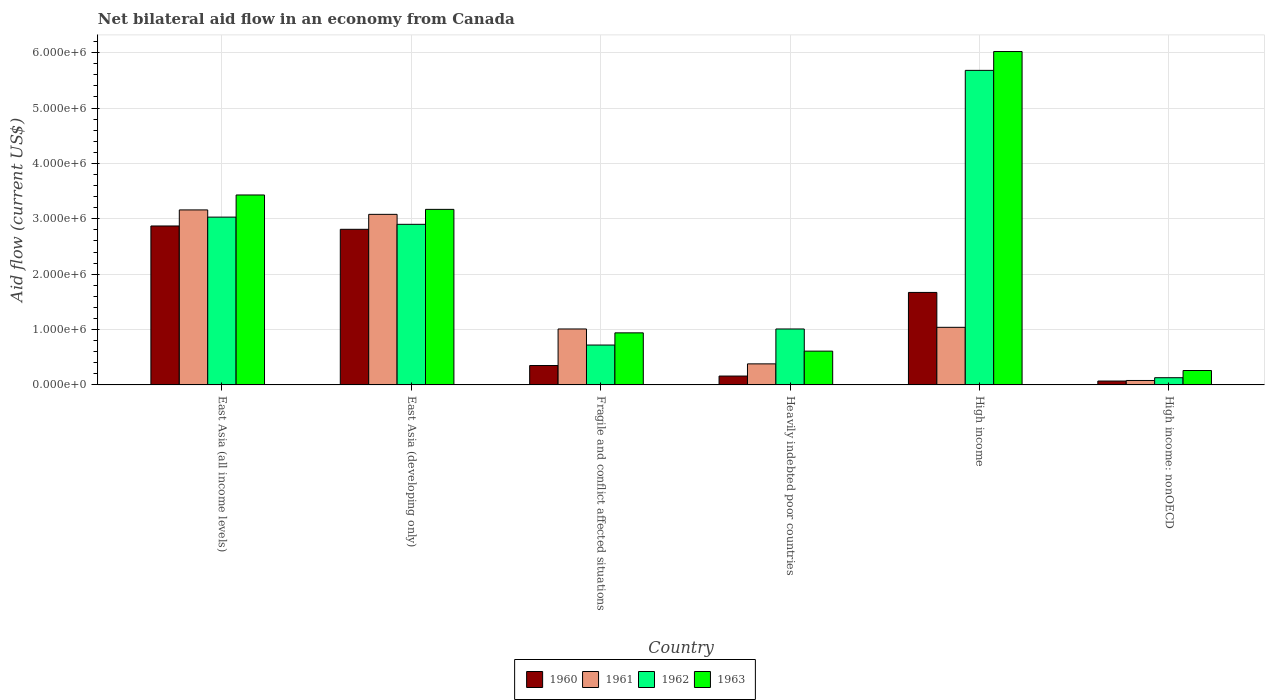How many groups of bars are there?
Offer a terse response. 6. Are the number of bars per tick equal to the number of legend labels?
Offer a very short reply. Yes. Are the number of bars on each tick of the X-axis equal?
Make the answer very short. Yes. How many bars are there on the 1st tick from the right?
Provide a short and direct response. 4. In how many cases, is the number of bars for a given country not equal to the number of legend labels?
Provide a succinct answer. 0. What is the net bilateral aid flow in 1961 in East Asia (all income levels)?
Ensure brevity in your answer.  3.16e+06. Across all countries, what is the maximum net bilateral aid flow in 1963?
Ensure brevity in your answer.  6.02e+06. Across all countries, what is the minimum net bilateral aid flow in 1961?
Ensure brevity in your answer.  8.00e+04. In which country was the net bilateral aid flow in 1960 minimum?
Your response must be concise. High income: nonOECD. What is the total net bilateral aid flow in 1962 in the graph?
Offer a terse response. 1.35e+07. What is the difference between the net bilateral aid flow in 1962 in East Asia (all income levels) and that in Heavily indebted poor countries?
Your answer should be very brief. 2.02e+06. What is the difference between the net bilateral aid flow in 1962 in Heavily indebted poor countries and the net bilateral aid flow in 1960 in High income: nonOECD?
Your response must be concise. 9.40e+05. What is the average net bilateral aid flow in 1961 per country?
Offer a very short reply. 1.46e+06. What is the difference between the net bilateral aid flow of/in 1960 and net bilateral aid flow of/in 1963 in Heavily indebted poor countries?
Your answer should be compact. -4.50e+05. In how many countries, is the net bilateral aid flow in 1961 greater than 3600000 US$?
Make the answer very short. 0. What is the ratio of the net bilateral aid flow in 1963 in East Asia (developing only) to that in Heavily indebted poor countries?
Offer a very short reply. 5.2. Is the net bilateral aid flow in 1961 in East Asia (all income levels) less than that in High income?
Ensure brevity in your answer.  No. Is the difference between the net bilateral aid flow in 1960 in East Asia (all income levels) and Fragile and conflict affected situations greater than the difference between the net bilateral aid flow in 1963 in East Asia (all income levels) and Fragile and conflict affected situations?
Your answer should be compact. Yes. What is the difference between the highest and the second highest net bilateral aid flow in 1962?
Ensure brevity in your answer.  2.78e+06. What is the difference between the highest and the lowest net bilateral aid flow in 1962?
Your response must be concise. 5.55e+06. In how many countries, is the net bilateral aid flow in 1960 greater than the average net bilateral aid flow in 1960 taken over all countries?
Offer a terse response. 3. Is it the case that in every country, the sum of the net bilateral aid flow in 1960 and net bilateral aid flow in 1961 is greater than the sum of net bilateral aid flow in 1963 and net bilateral aid flow in 1962?
Make the answer very short. No. What does the 3rd bar from the right in High income represents?
Keep it short and to the point. 1961. Is it the case that in every country, the sum of the net bilateral aid flow in 1961 and net bilateral aid flow in 1960 is greater than the net bilateral aid flow in 1963?
Give a very brief answer. No. How many countries are there in the graph?
Ensure brevity in your answer.  6. Does the graph contain grids?
Keep it short and to the point. Yes. How many legend labels are there?
Provide a short and direct response. 4. How are the legend labels stacked?
Give a very brief answer. Horizontal. What is the title of the graph?
Keep it short and to the point. Net bilateral aid flow in an economy from Canada. Does "1995" appear as one of the legend labels in the graph?
Offer a very short reply. No. What is the Aid flow (current US$) of 1960 in East Asia (all income levels)?
Your answer should be very brief. 2.87e+06. What is the Aid flow (current US$) of 1961 in East Asia (all income levels)?
Give a very brief answer. 3.16e+06. What is the Aid flow (current US$) in 1962 in East Asia (all income levels)?
Ensure brevity in your answer.  3.03e+06. What is the Aid flow (current US$) of 1963 in East Asia (all income levels)?
Make the answer very short. 3.43e+06. What is the Aid flow (current US$) of 1960 in East Asia (developing only)?
Provide a short and direct response. 2.81e+06. What is the Aid flow (current US$) in 1961 in East Asia (developing only)?
Provide a short and direct response. 3.08e+06. What is the Aid flow (current US$) of 1962 in East Asia (developing only)?
Your answer should be compact. 2.90e+06. What is the Aid flow (current US$) of 1963 in East Asia (developing only)?
Your answer should be compact. 3.17e+06. What is the Aid flow (current US$) of 1960 in Fragile and conflict affected situations?
Provide a succinct answer. 3.50e+05. What is the Aid flow (current US$) of 1961 in Fragile and conflict affected situations?
Ensure brevity in your answer.  1.01e+06. What is the Aid flow (current US$) of 1962 in Fragile and conflict affected situations?
Provide a short and direct response. 7.20e+05. What is the Aid flow (current US$) in 1963 in Fragile and conflict affected situations?
Your answer should be very brief. 9.40e+05. What is the Aid flow (current US$) in 1962 in Heavily indebted poor countries?
Provide a succinct answer. 1.01e+06. What is the Aid flow (current US$) in 1960 in High income?
Your response must be concise. 1.67e+06. What is the Aid flow (current US$) in 1961 in High income?
Offer a very short reply. 1.04e+06. What is the Aid flow (current US$) in 1962 in High income?
Ensure brevity in your answer.  5.68e+06. What is the Aid flow (current US$) of 1963 in High income?
Offer a terse response. 6.02e+06. Across all countries, what is the maximum Aid flow (current US$) in 1960?
Provide a short and direct response. 2.87e+06. Across all countries, what is the maximum Aid flow (current US$) of 1961?
Offer a very short reply. 3.16e+06. Across all countries, what is the maximum Aid flow (current US$) in 1962?
Make the answer very short. 5.68e+06. Across all countries, what is the maximum Aid flow (current US$) of 1963?
Keep it short and to the point. 6.02e+06. Across all countries, what is the minimum Aid flow (current US$) in 1960?
Your answer should be very brief. 7.00e+04. Across all countries, what is the minimum Aid flow (current US$) of 1962?
Offer a very short reply. 1.30e+05. What is the total Aid flow (current US$) in 1960 in the graph?
Provide a short and direct response. 7.93e+06. What is the total Aid flow (current US$) in 1961 in the graph?
Offer a very short reply. 8.75e+06. What is the total Aid flow (current US$) in 1962 in the graph?
Make the answer very short. 1.35e+07. What is the total Aid flow (current US$) of 1963 in the graph?
Ensure brevity in your answer.  1.44e+07. What is the difference between the Aid flow (current US$) of 1960 in East Asia (all income levels) and that in East Asia (developing only)?
Give a very brief answer. 6.00e+04. What is the difference between the Aid flow (current US$) of 1961 in East Asia (all income levels) and that in East Asia (developing only)?
Provide a short and direct response. 8.00e+04. What is the difference between the Aid flow (current US$) of 1962 in East Asia (all income levels) and that in East Asia (developing only)?
Keep it short and to the point. 1.30e+05. What is the difference between the Aid flow (current US$) of 1960 in East Asia (all income levels) and that in Fragile and conflict affected situations?
Provide a succinct answer. 2.52e+06. What is the difference between the Aid flow (current US$) in 1961 in East Asia (all income levels) and that in Fragile and conflict affected situations?
Ensure brevity in your answer.  2.15e+06. What is the difference between the Aid flow (current US$) in 1962 in East Asia (all income levels) and that in Fragile and conflict affected situations?
Make the answer very short. 2.31e+06. What is the difference between the Aid flow (current US$) in 1963 in East Asia (all income levels) and that in Fragile and conflict affected situations?
Your answer should be very brief. 2.49e+06. What is the difference between the Aid flow (current US$) in 1960 in East Asia (all income levels) and that in Heavily indebted poor countries?
Your answer should be compact. 2.71e+06. What is the difference between the Aid flow (current US$) in 1961 in East Asia (all income levels) and that in Heavily indebted poor countries?
Make the answer very short. 2.78e+06. What is the difference between the Aid flow (current US$) of 1962 in East Asia (all income levels) and that in Heavily indebted poor countries?
Your answer should be very brief. 2.02e+06. What is the difference between the Aid flow (current US$) of 1963 in East Asia (all income levels) and that in Heavily indebted poor countries?
Your response must be concise. 2.82e+06. What is the difference between the Aid flow (current US$) of 1960 in East Asia (all income levels) and that in High income?
Offer a very short reply. 1.20e+06. What is the difference between the Aid flow (current US$) in 1961 in East Asia (all income levels) and that in High income?
Offer a terse response. 2.12e+06. What is the difference between the Aid flow (current US$) in 1962 in East Asia (all income levels) and that in High income?
Your answer should be compact. -2.65e+06. What is the difference between the Aid flow (current US$) of 1963 in East Asia (all income levels) and that in High income?
Offer a very short reply. -2.59e+06. What is the difference between the Aid flow (current US$) in 1960 in East Asia (all income levels) and that in High income: nonOECD?
Offer a very short reply. 2.80e+06. What is the difference between the Aid flow (current US$) in 1961 in East Asia (all income levels) and that in High income: nonOECD?
Give a very brief answer. 3.08e+06. What is the difference between the Aid flow (current US$) of 1962 in East Asia (all income levels) and that in High income: nonOECD?
Make the answer very short. 2.90e+06. What is the difference between the Aid flow (current US$) in 1963 in East Asia (all income levels) and that in High income: nonOECD?
Offer a very short reply. 3.17e+06. What is the difference between the Aid flow (current US$) of 1960 in East Asia (developing only) and that in Fragile and conflict affected situations?
Keep it short and to the point. 2.46e+06. What is the difference between the Aid flow (current US$) of 1961 in East Asia (developing only) and that in Fragile and conflict affected situations?
Your answer should be compact. 2.07e+06. What is the difference between the Aid flow (current US$) in 1962 in East Asia (developing only) and that in Fragile and conflict affected situations?
Your answer should be compact. 2.18e+06. What is the difference between the Aid flow (current US$) in 1963 in East Asia (developing only) and that in Fragile and conflict affected situations?
Provide a short and direct response. 2.23e+06. What is the difference between the Aid flow (current US$) in 1960 in East Asia (developing only) and that in Heavily indebted poor countries?
Make the answer very short. 2.65e+06. What is the difference between the Aid flow (current US$) in 1961 in East Asia (developing only) and that in Heavily indebted poor countries?
Your answer should be compact. 2.70e+06. What is the difference between the Aid flow (current US$) of 1962 in East Asia (developing only) and that in Heavily indebted poor countries?
Keep it short and to the point. 1.89e+06. What is the difference between the Aid flow (current US$) in 1963 in East Asia (developing only) and that in Heavily indebted poor countries?
Your response must be concise. 2.56e+06. What is the difference between the Aid flow (current US$) in 1960 in East Asia (developing only) and that in High income?
Give a very brief answer. 1.14e+06. What is the difference between the Aid flow (current US$) of 1961 in East Asia (developing only) and that in High income?
Offer a very short reply. 2.04e+06. What is the difference between the Aid flow (current US$) in 1962 in East Asia (developing only) and that in High income?
Offer a terse response. -2.78e+06. What is the difference between the Aid flow (current US$) in 1963 in East Asia (developing only) and that in High income?
Keep it short and to the point. -2.85e+06. What is the difference between the Aid flow (current US$) in 1960 in East Asia (developing only) and that in High income: nonOECD?
Offer a very short reply. 2.74e+06. What is the difference between the Aid flow (current US$) of 1961 in East Asia (developing only) and that in High income: nonOECD?
Your response must be concise. 3.00e+06. What is the difference between the Aid flow (current US$) of 1962 in East Asia (developing only) and that in High income: nonOECD?
Give a very brief answer. 2.77e+06. What is the difference between the Aid flow (current US$) in 1963 in East Asia (developing only) and that in High income: nonOECD?
Offer a very short reply. 2.91e+06. What is the difference between the Aid flow (current US$) in 1961 in Fragile and conflict affected situations and that in Heavily indebted poor countries?
Offer a terse response. 6.30e+05. What is the difference between the Aid flow (current US$) of 1962 in Fragile and conflict affected situations and that in Heavily indebted poor countries?
Your answer should be very brief. -2.90e+05. What is the difference between the Aid flow (current US$) of 1963 in Fragile and conflict affected situations and that in Heavily indebted poor countries?
Make the answer very short. 3.30e+05. What is the difference between the Aid flow (current US$) in 1960 in Fragile and conflict affected situations and that in High income?
Make the answer very short. -1.32e+06. What is the difference between the Aid flow (current US$) of 1962 in Fragile and conflict affected situations and that in High income?
Give a very brief answer. -4.96e+06. What is the difference between the Aid flow (current US$) in 1963 in Fragile and conflict affected situations and that in High income?
Offer a terse response. -5.08e+06. What is the difference between the Aid flow (current US$) in 1961 in Fragile and conflict affected situations and that in High income: nonOECD?
Ensure brevity in your answer.  9.30e+05. What is the difference between the Aid flow (current US$) of 1962 in Fragile and conflict affected situations and that in High income: nonOECD?
Your answer should be very brief. 5.90e+05. What is the difference between the Aid flow (current US$) of 1963 in Fragile and conflict affected situations and that in High income: nonOECD?
Your response must be concise. 6.80e+05. What is the difference between the Aid flow (current US$) of 1960 in Heavily indebted poor countries and that in High income?
Give a very brief answer. -1.51e+06. What is the difference between the Aid flow (current US$) of 1961 in Heavily indebted poor countries and that in High income?
Ensure brevity in your answer.  -6.60e+05. What is the difference between the Aid flow (current US$) in 1962 in Heavily indebted poor countries and that in High income?
Give a very brief answer. -4.67e+06. What is the difference between the Aid flow (current US$) of 1963 in Heavily indebted poor countries and that in High income?
Make the answer very short. -5.41e+06. What is the difference between the Aid flow (current US$) in 1961 in Heavily indebted poor countries and that in High income: nonOECD?
Offer a terse response. 3.00e+05. What is the difference between the Aid flow (current US$) of 1962 in Heavily indebted poor countries and that in High income: nonOECD?
Your answer should be compact. 8.80e+05. What is the difference between the Aid flow (current US$) of 1963 in Heavily indebted poor countries and that in High income: nonOECD?
Your answer should be compact. 3.50e+05. What is the difference between the Aid flow (current US$) of 1960 in High income and that in High income: nonOECD?
Your answer should be compact. 1.60e+06. What is the difference between the Aid flow (current US$) of 1961 in High income and that in High income: nonOECD?
Your answer should be compact. 9.60e+05. What is the difference between the Aid flow (current US$) in 1962 in High income and that in High income: nonOECD?
Keep it short and to the point. 5.55e+06. What is the difference between the Aid flow (current US$) in 1963 in High income and that in High income: nonOECD?
Give a very brief answer. 5.76e+06. What is the difference between the Aid flow (current US$) in 1960 in East Asia (all income levels) and the Aid flow (current US$) in 1961 in East Asia (developing only)?
Your response must be concise. -2.10e+05. What is the difference between the Aid flow (current US$) in 1960 in East Asia (all income levels) and the Aid flow (current US$) in 1962 in East Asia (developing only)?
Offer a very short reply. -3.00e+04. What is the difference between the Aid flow (current US$) in 1961 in East Asia (all income levels) and the Aid flow (current US$) in 1962 in East Asia (developing only)?
Your answer should be compact. 2.60e+05. What is the difference between the Aid flow (current US$) in 1961 in East Asia (all income levels) and the Aid flow (current US$) in 1963 in East Asia (developing only)?
Offer a terse response. -10000. What is the difference between the Aid flow (current US$) in 1960 in East Asia (all income levels) and the Aid flow (current US$) in 1961 in Fragile and conflict affected situations?
Make the answer very short. 1.86e+06. What is the difference between the Aid flow (current US$) in 1960 in East Asia (all income levels) and the Aid flow (current US$) in 1962 in Fragile and conflict affected situations?
Give a very brief answer. 2.15e+06. What is the difference between the Aid flow (current US$) of 1960 in East Asia (all income levels) and the Aid flow (current US$) of 1963 in Fragile and conflict affected situations?
Ensure brevity in your answer.  1.93e+06. What is the difference between the Aid flow (current US$) in 1961 in East Asia (all income levels) and the Aid flow (current US$) in 1962 in Fragile and conflict affected situations?
Ensure brevity in your answer.  2.44e+06. What is the difference between the Aid flow (current US$) of 1961 in East Asia (all income levels) and the Aid flow (current US$) of 1963 in Fragile and conflict affected situations?
Provide a succinct answer. 2.22e+06. What is the difference between the Aid flow (current US$) in 1962 in East Asia (all income levels) and the Aid flow (current US$) in 1963 in Fragile and conflict affected situations?
Ensure brevity in your answer.  2.09e+06. What is the difference between the Aid flow (current US$) in 1960 in East Asia (all income levels) and the Aid flow (current US$) in 1961 in Heavily indebted poor countries?
Provide a succinct answer. 2.49e+06. What is the difference between the Aid flow (current US$) in 1960 in East Asia (all income levels) and the Aid flow (current US$) in 1962 in Heavily indebted poor countries?
Provide a short and direct response. 1.86e+06. What is the difference between the Aid flow (current US$) of 1960 in East Asia (all income levels) and the Aid flow (current US$) of 1963 in Heavily indebted poor countries?
Your response must be concise. 2.26e+06. What is the difference between the Aid flow (current US$) in 1961 in East Asia (all income levels) and the Aid flow (current US$) in 1962 in Heavily indebted poor countries?
Ensure brevity in your answer.  2.15e+06. What is the difference between the Aid flow (current US$) in 1961 in East Asia (all income levels) and the Aid flow (current US$) in 1963 in Heavily indebted poor countries?
Provide a short and direct response. 2.55e+06. What is the difference between the Aid flow (current US$) of 1962 in East Asia (all income levels) and the Aid flow (current US$) of 1963 in Heavily indebted poor countries?
Provide a succinct answer. 2.42e+06. What is the difference between the Aid flow (current US$) in 1960 in East Asia (all income levels) and the Aid flow (current US$) in 1961 in High income?
Your answer should be very brief. 1.83e+06. What is the difference between the Aid flow (current US$) of 1960 in East Asia (all income levels) and the Aid flow (current US$) of 1962 in High income?
Offer a very short reply. -2.81e+06. What is the difference between the Aid flow (current US$) of 1960 in East Asia (all income levels) and the Aid flow (current US$) of 1963 in High income?
Ensure brevity in your answer.  -3.15e+06. What is the difference between the Aid flow (current US$) in 1961 in East Asia (all income levels) and the Aid flow (current US$) in 1962 in High income?
Provide a succinct answer. -2.52e+06. What is the difference between the Aid flow (current US$) in 1961 in East Asia (all income levels) and the Aid flow (current US$) in 1963 in High income?
Make the answer very short. -2.86e+06. What is the difference between the Aid flow (current US$) of 1962 in East Asia (all income levels) and the Aid flow (current US$) of 1963 in High income?
Offer a terse response. -2.99e+06. What is the difference between the Aid flow (current US$) in 1960 in East Asia (all income levels) and the Aid flow (current US$) in 1961 in High income: nonOECD?
Provide a short and direct response. 2.79e+06. What is the difference between the Aid flow (current US$) of 1960 in East Asia (all income levels) and the Aid flow (current US$) of 1962 in High income: nonOECD?
Keep it short and to the point. 2.74e+06. What is the difference between the Aid flow (current US$) of 1960 in East Asia (all income levels) and the Aid flow (current US$) of 1963 in High income: nonOECD?
Offer a very short reply. 2.61e+06. What is the difference between the Aid flow (current US$) of 1961 in East Asia (all income levels) and the Aid flow (current US$) of 1962 in High income: nonOECD?
Your answer should be very brief. 3.03e+06. What is the difference between the Aid flow (current US$) in 1961 in East Asia (all income levels) and the Aid flow (current US$) in 1963 in High income: nonOECD?
Your response must be concise. 2.90e+06. What is the difference between the Aid flow (current US$) of 1962 in East Asia (all income levels) and the Aid flow (current US$) of 1963 in High income: nonOECD?
Make the answer very short. 2.77e+06. What is the difference between the Aid flow (current US$) of 1960 in East Asia (developing only) and the Aid flow (current US$) of 1961 in Fragile and conflict affected situations?
Keep it short and to the point. 1.80e+06. What is the difference between the Aid flow (current US$) of 1960 in East Asia (developing only) and the Aid flow (current US$) of 1962 in Fragile and conflict affected situations?
Your response must be concise. 2.09e+06. What is the difference between the Aid flow (current US$) in 1960 in East Asia (developing only) and the Aid flow (current US$) in 1963 in Fragile and conflict affected situations?
Give a very brief answer. 1.87e+06. What is the difference between the Aid flow (current US$) of 1961 in East Asia (developing only) and the Aid flow (current US$) of 1962 in Fragile and conflict affected situations?
Offer a very short reply. 2.36e+06. What is the difference between the Aid flow (current US$) of 1961 in East Asia (developing only) and the Aid flow (current US$) of 1963 in Fragile and conflict affected situations?
Provide a succinct answer. 2.14e+06. What is the difference between the Aid flow (current US$) in 1962 in East Asia (developing only) and the Aid flow (current US$) in 1963 in Fragile and conflict affected situations?
Your answer should be compact. 1.96e+06. What is the difference between the Aid flow (current US$) in 1960 in East Asia (developing only) and the Aid flow (current US$) in 1961 in Heavily indebted poor countries?
Keep it short and to the point. 2.43e+06. What is the difference between the Aid flow (current US$) of 1960 in East Asia (developing only) and the Aid flow (current US$) of 1962 in Heavily indebted poor countries?
Ensure brevity in your answer.  1.80e+06. What is the difference between the Aid flow (current US$) in 1960 in East Asia (developing only) and the Aid flow (current US$) in 1963 in Heavily indebted poor countries?
Your answer should be very brief. 2.20e+06. What is the difference between the Aid flow (current US$) of 1961 in East Asia (developing only) and the Aid flow (current US$) of 1962 in Heavily indebted poor countries?
Your response must be concise. 2.07e+06. What is the difference between the Aid flow (current US$) in 1961 in East Asia (developing only) and the Aid flow (current US$) in 1963 in Heavily indebted poor countries?
Make the answer very short. 2.47e+06. What is the difference between the Aid flow (current US$) of 1962 in East Asia (developing only) and the Aid flow (current US$) of 1963 in Heavily indebted poor countries?
Provide a succinct answer. 2.29e+06. What is the difference between the Aid flow (current US$) of 1960 in East Asia (developing only) and the Aid flow (current US$) of 1961 in High income?
Provide a succinct answer. 1.77e+06. What is the difference between the Aid flow (current US$) in 1960 in East Asia (developing only) and the Aid flow (current US$) in 1962 in High income?
Your response must be concise. -2.87e+06. What is the difference between the Aid flow (current US$) of 1960 in East Asia (developing only) and the Aid flow (current US$) of 1963 in High income?
Keep it short and to the point. -3.21e+06. What is the difference between the Aid flow (current US$) of 1961 in East Asia (developing only) and the Aid flow (current US$) of 1962 in High income?
Your response must be concise. -2.60e+06. What is the difference between the Aid flow (current US$) in 1961 in East Asia (developing only) and the Aid flow (current US$) in 1963 in High income?
Your answer should be very brief. -2.94e+06. What is the difference between the Aid flow (current US$) of 1962 in East Asia (developing only) and the Aid flow (current US$) of 1963 in High income?
Your answer should be compact. -3.12e+06. What is the difference between the Aid flow (current US$) of 1960 in East Asia (developing only) and the Aid flow (current US$) of 1961 in High income: nonOECD?
Ensure brevity in your answer.  2.73e+06. What is the difference between the Aid flow (current US$) in 1960 in East Asia (developing only) and the Aid flow (current US$) in 1962 in High income: nonOECD?
Offer a very short reply. 2.68e+06. What is the difference between the Aid flow (current US$) of 1960 in East Asia (developing only) and the Aid flow (current US$) of 1963 in High income: nonOECD?
Keep it short and to the point. 2.55e+06. What is the difference between the Aid flow (current US$) of 1961 in East Asia (developing only) and the Aid flow (current US$) of 1962 in High income: nonOECD?
Offer a terse response. 2.95e+06. What is the difference between the Aid flow (current US$) of 1961 in East Asia (developing only) and the Aid flow (current US$) of 1963 in High income: nonOECD?
Give a very brief answer. 2.82e+06. What is the difference between the Aid flow (current US$) in 1962 in East Asia (developing only) and the Aid flow (current US$) in 1963 in High income: nonOECD?
Provide a short and direct response. 2.64e+06. What is the difference between the Aid flow (current US$) in 1960 in Fragile and conflict affected situations and the Aid flow (current US$) in 1962 in Heavily indebted poor countries?
Your answer should be very brief. -6.60e+05. What is the difference between the Aid flow (current US$) in 1960 in Fragile and conflict affected situations and the Aid flow (current US$) in 1963 in Heavily indebted poor countries?
Offer a terse response. -2.60e+05. What is the difference between the Aid flow (current US$) in 1961 in Fragile and conflict affected situations and the Aid flow (current US$) in 1963 in Heavily indebted poor countries?
Ensure brevity in your answer.  4.00e+05. What is the difference between the Aid flow (current US$) in 1962 in Fragile and conflict affected situations and the Aid flow (current US$) in 1963 in Heavily indebted poor countries?
Offer a very short reply. 1.10e+05. What is the difference between the Aid flow (current US$) of 1960 in Fragile and conflict affected situations and the Aid flow (current US$) of 1961 in High income?
Provide a succinct answer. -6.90e+05. What is the difference between the Aid flow (current US$) of 1960 in Fragile and conflict affected situations and the Aid flow (current US$) of 1962 in High income?
Make the answer very short. -5.33e+06. What is the difference between the Aid flow (current US$) in 1960 in Fragile and conflict affected situations and the Aid flow (current US$) in 1963 in High income?
Ensure brevity in your answer.  -5.67e+06. What is the difference between the Aid flow (current US$) in 1961 in Fragile and conflict affected situations and the Aid flow (current US$) in 1962 in High income?
Your answer should be very brief. -4.67e+06. What is the difference between the Aid flow (current US$) in 1961 in Fragile and conflict affected situations and the Aid flow (current US$) in 1963 in High income?
Offer a very short reply. -5.01e+06. What is the difference between the Aid flow (current US$) in 1962 in Fragile and conflict affected situations and the Aid flow (current US$) in 1963 in High income?
Keep it short and to the point. -5.30e+06. What is the difference between the Aid flow (current US$) in 1960 in Fragile and conflict affected situations and the Aid flow (current US$) in 1961 in High income: nonOECD?
Keep it short and to the point. 2.70e+05. What is the difference between the Aid flow (current US$) in 1960 in Fragile and conflict affected situations and the Aid flow (current US$) in 1962 in High income: nonOECD?
Provide a short and direct response. 2.20e+05. What is the difference between the Aid flow (current US$) in 1961 in Fragile and conflict affected situations and the Aid flow (current US$) in 1962 in High income: nonOECD?
Offer a very short reply. 8.80e+05. What is the difference between the Aid flow (current US$) in 1961 in Fragile and conflict affected situations and the Aid flow (current US$) in 1963 in High income: nonOECD?
Offer a terse response. 7.50e+05. What is the difference between the Aid flow (current US$) of 1962 in Fragile and conflict affected situations and the Aid flow (current US$) of 1963 in High income: nonOECD?
Keep it short and to the point. 4.60e+05. What is the difference between the Aid flow (current US$) of 1960 in Heavily indebted poor countries and the Aid flow (current US$) of 1961 in High income?
Provide a short and direct response. -8.80e+05. What is the difference between the Aid flow (current US$) in 1960 in Heavily indebted poor countries and the Aid flow (current US$) in 1962 in High income?
Keep it short and to the point. -5.52e+06. What is the difference between the Aid flow (current US$) of 1960 in Heavily indebted poor countries and the Aid flow (current US$) of 1963 in High income?
Provide a succinct answer. -5.86e+06. What is the difference between the Aid flow (current US$) in 1961 in Heavily indebted poor countries and the Aid flow (current US$) in 1962 in High income?
Make the answer very short. -5.30e+06. What is the difference between the Aid flow (current US$) in 1961 in Heavily indebted poor countries and the Aid flow (current US$) in 1963 in High income?
Offer a very short reply. -5.64e+06. What is the difference between the Aid flow (current US$) of 1962 in Heavily indebted poor countries and the Aid flow (current US$) of 1963 in High income?
Keep it short and to the point. -5.01e+06. What is the difference between the Aid flow (current US$) in 1960 in Heavily indebted poor countries and the Aid flow (current US$) in 1962 in High income: nonOECD?
Offer a terse response. 3.00e+04. What is the difference between the Aid flow (current US$) in 1962 in Heavily indebted poor countries and the Aid flow (current US$) in 1963 in High income: nonOECD?
Provide a short and direct response. 7.50e+05. What is the difference between the Aid flow (current US$) in 1960 in High income and the Aid flow (current US$) in 1961 in High income: nonOECD?
Provide a succinct answer. 1.59e+06. What is the difference between the Aid flow (current US$) in 1960 in High income and the Aid flow (current US$) in 1962 in High income: nonOECD?
Your answer should be compact. 1.54e+06. What is the difference between the Aid flow (current US$) of 1960 in High income and the Aid flow (current US$) of 1963 in High income: nonOECD?
Your answer should be very brief. 1.41e+06. What is the difference between the Aid flow (current US$) in 1961 in High income and the Aid flow (current US$) in 1962 in High income: nonOECD?
Make the answer very short. 9.10e+05. What is the difference between the Aid flow (current US$) in 1961 in High income and the Aid flow (current US$) in 1963 in High income: nonOECD?
Your answer should be very brief. 7.80e+05. What is the difference between the Aid flow (current US$) in 1962 in High income and the Aid flow (current US$) in 1963 in High income: nonOECD?
Offer a very short reply. 5.42e+06. What is the average Aid flow (current US$) of 1960 per country?
Your answer should be compact. 1.32e+06. What is the average Aid flow (current US$) in 1961 per country?
Offer a terse response. 1.46e+06. What is the average Aid flow (current US$) in 1962 per country?
Provide a short and direct response. 2.24e+06. What is the average Aid flow (current US$) in 1963 per country?
Ensure brevity in your answer.  2.40e+06. What is the difference between the Aid flow (current US$) of 1960 and Aid flow (current US$) of 1962 in East Asia (all income levels)?
Keep it short and to the point. -1.60e+05. What is the difference between the Aid flow (current US$) in 1960 and Aid flow (current US$) in 1963 in East Asia (all income levels)?
Offer a very short reply. -5.60e+05. What is the difference between the Aid flow (current US$) in 1961 and Aid flow (current US$) in 1962 in East Asia (all income levels)?
Offer a terse response. 1.30e+05. What is the difference between the Aid flow (current US$) in 1961 and Aid flow (current US$) in 1963 in East Asia (all income levels)?
Offer a terse response. -2.70e+05. What is the difference between the Aid flow (current US$) of 1962 and Aid flow (current US$) of 1963 in East Asia (all income levels)?
Your answer should be very brief. -4.00e+05. What is the difference between the Aid flow (current US$) of 1960 and Aid flow (current US$) of 1963 in East Asia (developing only)?
Offer a very short reply. -3.60e+05. What is the difference between the Aid flow (current US$) of 1961 and Aid flow (current US$) of 1962 in East Asia (developing only)?
Keep it short and to the point. 1.80e+05. What is the difference between the Aid flow (current US$) of 1961 and Aid flow (current US$) of 1963 in East Asia (developing only)?
Ensure brevity in your answer.  -9.00e+04. What is the difference between the Aid flow (current US$) of 1960 and Aid flow (current US$) of 1961 in Fragile and conflict affected situations?
Provide a short and direct response. -6.60e+05. What is the difference between the Aid flow (current US$) of 1960 and Aid flow (current US$) of 1962 in Fragile and conflict affected situations?
Provide a succinct answer. -3.70e+05. What is the difference between the Aid flow (current US$) in 1960 and Aid flow (current US$) in 1963 in Fragile and conflict affected situations?
Offer a terse response. -5.90e+05. What is the difference between the Aid flow (current US$) of 1962 and Aid flow (current US$) of 1963 in Fragile and conflict affected situations?
Provide a short and direct response. -2.20e+05. What is the difference between the Aid flow (current US$) in 1960 and Aid flow (current US$) in 1961 in Heavily indebted poor countries?
Make the answer very short. -2.20e+05. What is the difference between the Aid flow (current US$) of 1960 and Aid flow (current US$) of 1962 in Heavily indebted poor countries?
Make the answer very short. -8.50e+05. What is the difference between the Aid flow (current US$) of 1960 and Aid flow (current US$) of 1963 in Heavily indebted poor countries?
Give a very brief answer. -4.50e+05. What is the difference between the Aid flow (current US$) of 1961 and Aid flow (current US$) of 1962 in Heavily indebted poor countries?
Your answer should be compact. -6.30e+05. What is the difference between the Aid flow (current US$) in 1961 and Aid flow (current US$) in 1963 in Heavily indebted poor countries?
Your response must be concise. -2.30e+05. What is the difference between the Aid flow (current US$) in 1962 and Aid flow (current US$) in 1963 in Heavily indebted poor countries?
Give a very brief answer. 4.00e+05. What is the difference between the Aid flow (current US$) of 1960 and Aid flow (current US$) of 1961 in High income?
Your answer should be very brief. 6.30e+05. What is the difference between the Aid flow (current US$) in 1960 and Aid flow (current US$) in 1962 in High income?
Your response must be concise. -4.01e+06. What is the difference between the Aid flow (current US$) in 1960 and Aid flow (current US$) in 1963 in High income?
Ensure brevity in your answer.  -4.35e+06. What is the difference between the Aid flow (current US$) in 1961 and Aid flow (current US$) in 1962 in High income?
Provide a succinct answer. -4.64e+06. What is the difference between the Aid flow (current US$) of 1961 and Aid flow (current US$) of 1963 in High income?
Offer a very short reply. -4.98e+06. What is the difference between the Aid flow (current US$) in 1962 and Aid flow (current US$) in 1963 in High income?
Make the answer very short. -3.40e+05. What is the difference between the Aid flow (current US$) in 1960 and Aid flow (current US$) in 1961 in High income: nonOECD?
Provide a succinct answer. -10000. What is the difference between the Aid flow (current US$) in 1961 and Aid flow (current US$) in 1963 in High income: nonOECD?
Provide a short and direct response. -1.80e+05. What is the difference between the Aid flow (current US$) in 1962 and Aid flow (current US$) in 1963 in High income: nonOECD?
Your answer should be compact. -1.30e+05. What is the ratio of the Aid flow (current US$) in 1960 in East Asia (all income levels) to that in East Asia (developing only)?
Your response must be concise. 1.02. What is the ratio of the Aid flow (current US$) in 1962 in East Asia (all income levels) to that in East Asia (developing only)?
Provide a succinct answer. 1.04. What is the ratio of the Aid flow (current US$) of 1963 in East Asia (all income levels) to that in East Asia (developing only)?
Give a very brief answer. 1.08. What is the ratio of the Aid flow (current US$) in 1961 in East Asia (all income levels) to that in Fragile and conflict affected situations?
Provide a succinct answer. 3.13. What is the ratio of the Aid flow (current US$) in 1962 in East Asia (all income levels) to that in Fragile and conflict affected situations?
Offer a terse response. 4.21. What is the ratio of the Aid flow (current US$) of 1963 in East Asia (all income levels) to that in Fragile and conflict affected situations?
Offer a very short reply. 3.65. What is the ratio of the Aid flow (current US$) of 1960 in East Asia (all income levels) to that in Heavily indebted poor countries?
Ensure brevity in your answer.  17.94. What is the ratio of the Aid flow (current US$) in 1961 in East Asia (all income levels) to that in Heavily indebted poor countries?
Your answer should be very brief. 8.32. What is the ratio of the Aid flow (current US$) in 1962 in East Asia (all income levels) to that in Heavily indebted poor countries?
Give a very brief answer. 3. What is the ratio of the Aid flow (current US$) in 1963 in East Asia (all income levels) to that in Heavily indebted poor countries?
Your answer should be very brief. 5.62. What is the ratio of the Aid flow (current US$) in 1960 in East Asia (all income levels) to that in High income?
Give a very brief answer. 1.72. What is the ratio of the Aid flow (current US$) in 1961 in East Asia (all income levels) to that in High income?
Provide a succinct answer. 3.04. What is the ratio of the Aid flow (current US$) of 1962 in East Asia (all income levels) to that in High income?
Your answer should be compact. 0.53. What is the ratio of the Aid flow (current US$) in 1963 in East Asia (all income levels) to that in High income?
Offer a terse response. 0.57. What is the ratio of the Aid flow (current US$) of 1960 in East Asia (all income levels) to that in High income: nonOECD?
Your answer should be compact. 41. What is the ratio of the Aid flow (current US$) in 1961 in East Asia (all income levels) to that in High income: nonOECD?
Provide a succinct answer. 39.5. What is the ratio of the Aid flow (current US$) in 1962 in East Asia (all income levels) to that in High income: nonOECD?
Give a very brief answer. 23.31. What is the ratio of the Aid flow (current US$) of 1963 in East Asia (all income levels) to that in High income: nonOECD?
Your answer should be compact. 13.19. What is the ratio of the Aid flow (current US$) in 1960 in East Asia (developing only) to that in Fragile and conflict affected situations?
Your answer should be compact. 8.03. What is the ratio of the Aid flow (current US$) of 1961 in East Asia (developing only) to that in Fragile and conflict affected situations?
Your answer should be very brief. 3.05. What is the ratio of the Aid flow (current US$) in 1962 in East Asia (developing only) to that in Fragile and conflict affected situations?
Provide a short and direct response. 4.03. What is the ratio of the Aid flow (current US$) of 1963 in East Asia (developing only) to that in Fragile and conflict affected situations?
Keep it short and to the point. 3.37. What is the ratio of the Aid flow (current US$) in 1960 in East Asia (developing only) to that in Heavily indebted poor countries?
Provide a short and direct response. 17.56. What is the ratio of the Aid flow (current US$) in 1961 in East Asia (developing only) to that in Heavily indebted poor countries?
Make the answer very short. 8.11. What is the ratio of the Aid flow (current US$) of 1962 in East Asia (developing only) to that in Heavily indebted poor countries?
Provide a succinct answer. 2.87. What is the ratio of the Aid flow (current US$) in 1963 in East Asia (developing only) to that in Heavily indebted poor countries?
Provide a short and direct response. 5.2. What is the ratio of the Aid flow (current US$) of 1960 in East Asia (developing only) to that in High income?
Offer a terse response. 1.68. What is the ratio of the Aid flow (current US$) in 1961 in East Asia (developing only) to that in High income?
Your response must be concise. 2.96. What is the ratio of the Aid flow (current US$) in 1962 in East Asia (developing only) to that in High income?
Give a very brief answer. 0.51. What is the ratio of the Aid flow (current US$) in 1963 in East Asia (developing only) to that in High income?
Provide a succinct answer. 0.53. What is the ratio of the Aid flow (current US$) in 1960 in East Asia (developing only) to that in High income: nonOECD?
Provide a short and direct response. 40.14. What is the ratio of the Aid flow (current US$) of 1961 in East Asia (developing only) to that in High income: nonOECD?
Offer a terse response. 38.5. What is the ratio of the Aid flow (current US$) of 1962 in East Asia (developing only) to that in High income: nonOECD?
Your answer should be very brief. 22.31. What is the ratio of the Aid flow (current US$) in 1963 in East Asia (developing only) to that in High income: nonOECD?
Keep it short and to the point. 12.19. What is the ratio of the Aid flow (current US$) in 1960 in Fragile and conflict affected situations to that in Heavily indebted poor countries?
Keep it short and to the point. 2.19. What is the ratio of the Aid flow (current US$) of 1961 in Fragile and conflict affected situations to that in Heavily indebted poor countries?
Make the answer very short. 2.66. What is the ratio of the Aid flow (current US$) of 1962 in Fragile and conflict affected situations to that in Heavily indebted poor countries?
Offer a terse response. 0.71. What is the ratio of the Aid flow (current US$) in 1963 in Fragile and conflict affected situations to that in Heavily indebted poor countries?
Provide a short and direct response. 1.54. What is the ratio of the Aid flow (current US$) in 1960 in Fragile and conflict affected situations to that in High income?
Your answer should be very brief. 0.21. What is the ratio of the Aid flow (current US$) of 1961 in Fragile and conflict affected situations to that in High income?
Offer a terse response. 0.97. What is the ratio of the Aid flow (current US$) of 1962 in Fragile and conflict affected situations to that in High income?
Keep it short and to the point. 0.13. What is the ratio of the Aid flow (current US$) in 1963 in Fragile and conflict affected situations to that in High income?
Offer a terse response. 0.16. What is the ratio of the Aid flow (current US$) of 1960 in Fragile and conflict affected situations to that in High income: nonOECD?
Your answer should be very brief. 5. What is the ratio of the Aid flow (current US$) in 1961 in Fragile and conflict affected situations to that in High income: nonOECD?
Ensure brevity in your answer.  12.62. What is the ratio of the Aid flow (current US$) in 1962 in Fragile and conflict affected situations to that in High income: nonOECD?
Keep it short and to the point. 5.54. What is the ratio of the Aid flow (current US$) of 1963 in Fragile and conflict affected situations to that in High income: nonOECD?
Keep it short and to the point. 3.62. What is the ratio of the Aid flow (current US$) of 1960 in Heavily indebted poor countries to that in High income?
Your response must be concise. 0.1. What is the ratio of the Aid flow (current US$) in 1961 in Heavily indebted poor countries to that in High income?
Provide a succinct answer. 0.37. What is the ratio of the Aid flow (current US$) in 1962 in Heavily indebted poor countries to that in High income?
Give a very brief answer. 0.18. What is the ratio of the Aid flow (current US$) in 1963 in Heavily indebted poor countries to that in High income?
Your response must be concise. 0.1. What is the ratio of the Aid flow (current US$) in 1960 in Heavily indebted poor countries to that in High income: nonOECD?
Ensure brevity in your answer.  2.29. What is the ratio of the Aid flow (current US$) in 1961 in Heavily indebted poor countries to that in High income: nonOECD?
Keep it short and to the point. 4.75. What is the ratio of the Aid flow (current US$) of 1962 in Heavily indebted poor countries to that in High income: nonOECD?
Provide a short and direct response. 7.77. What is the ratio of the Aid flow (current US$) of 1963 in Heavily indebted poor countries to that in High income: nonOECD?
Ensure brevity in your answer.  2.35. What is the ratio of the Aid flow (current US$) of 1960 in High income to that in High income: nonOECD?
Make the answer very short. 23.86. What is the ratio of the Aid flow (current US$) in 1961 in High income to that in High income: nonOECD?
Your answer should be very brief. 13. What is the ratio of the Aid flow (current US$) of 1962 in High income to that in High income: nonOECD?
Keep it short and to the point. 43.69. What is the ratio of the Aid flow (current US$) in 1963 in High income to that in High income: nonOECD?
Keep it short and to the point. 23.15. What is the difference between the highest and the second highest Aid flow (current US$) of 1962?
Provide a succinct answer. 2.65e+06. What is the difference between the highest and the second highest Aid flow (current US$) of 1963?
Provide a succinct answer. 2.59e+06. What is the difference between the highest and the lowest Aid flow (current US$) of 1960?
Offer a very short reply. 2.80e+06. What is the difference between the highest and the lowest Aid flow (current US$) in 1961?
Ensure brevity in your answer.  3.08e+06. What is the difference between the highest and the lowest Aid flow (current US$) in 1962?
Keep it short and to the point. 5.55e+06. What is the difference between the highest and the lowest Aid flow (current US$) of 1963?
Offer a terse response. 5.76e+06. 